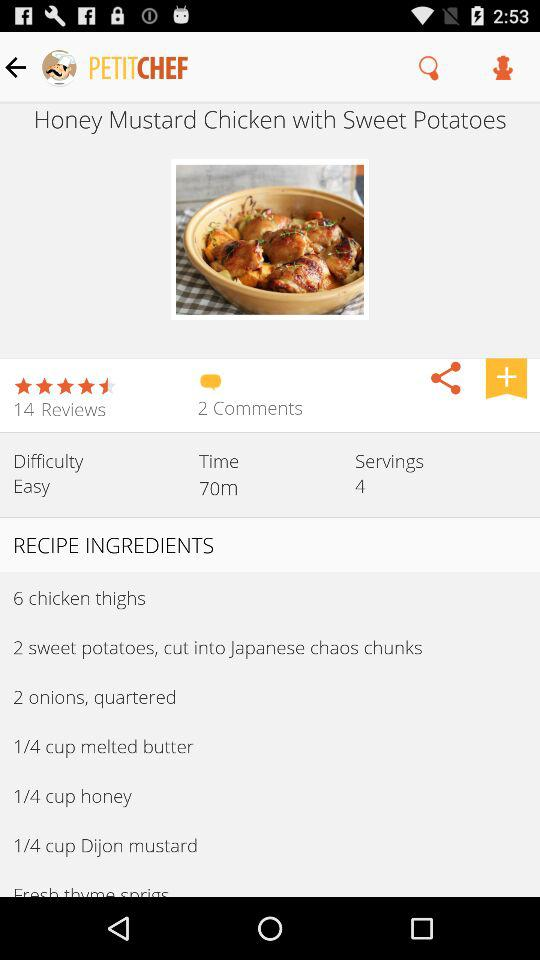How many comments are there for the recipe? There are 2 comments for the recipe. 